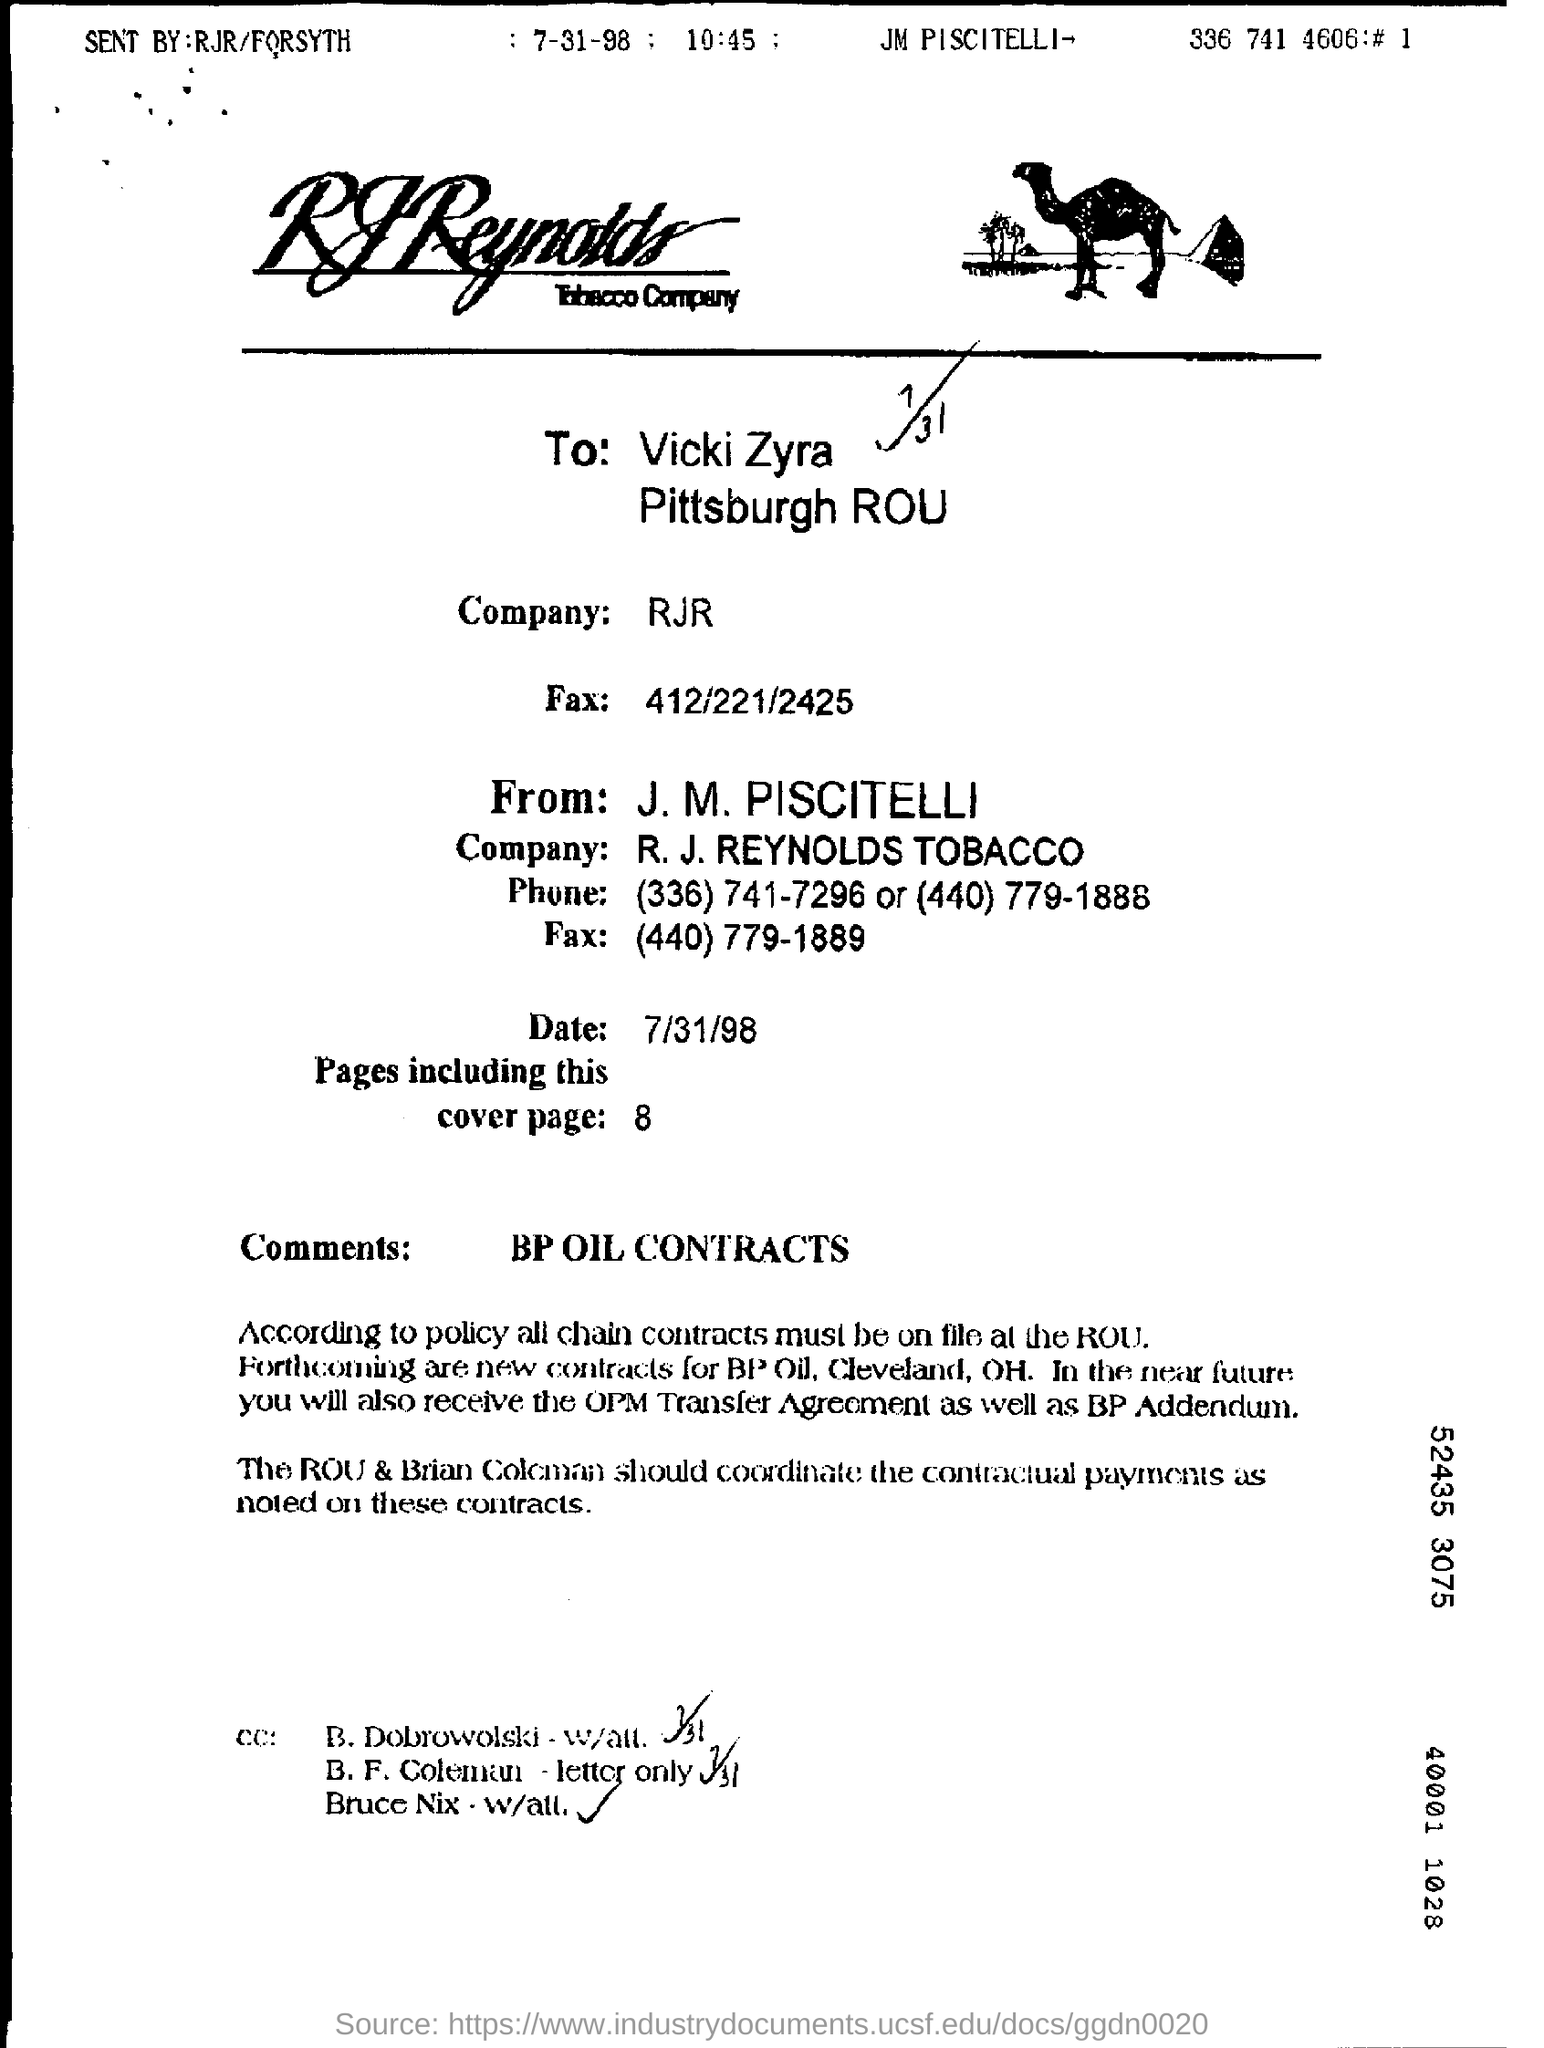To Whom is this document addressed to?
Provide a short and direct response. Vicki zyra      pittsburgh rou. What is the total no of pages in the fax including cover page?
Give a very brief answer. 8. What is the Date?
Provide a short and direct response. 7/31/98. 